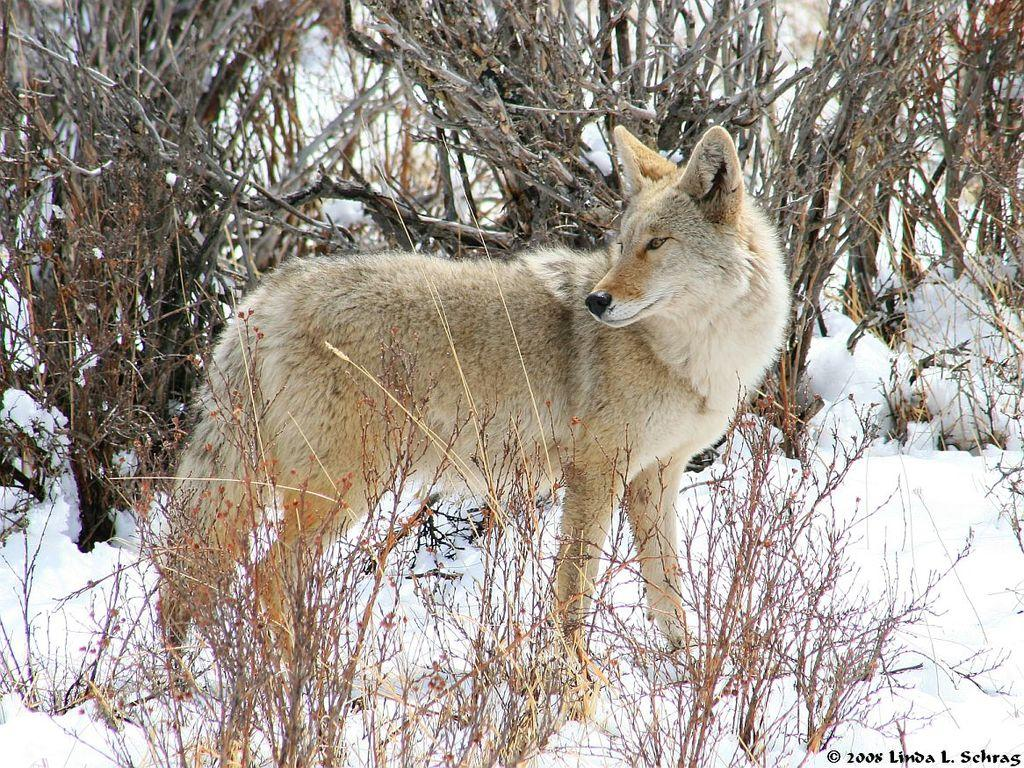What animal can be seen in the image? There is a jackal in the image. What is the jackal's position in relation to the ground? The jackal is standing on the ground. What type of terrain is depicted in the image? There is snow on the ground. What other natural elements can be seen in the image? There are plants on the ground and dry trees in the background of the image. What type of pets are visible in the image? There are no pets visible in the image; it features a jackal standing on snow-covered ground. How does the jackal's stomach appear in the image? The image does not show the jackal's stomach, so it cannot be described. 